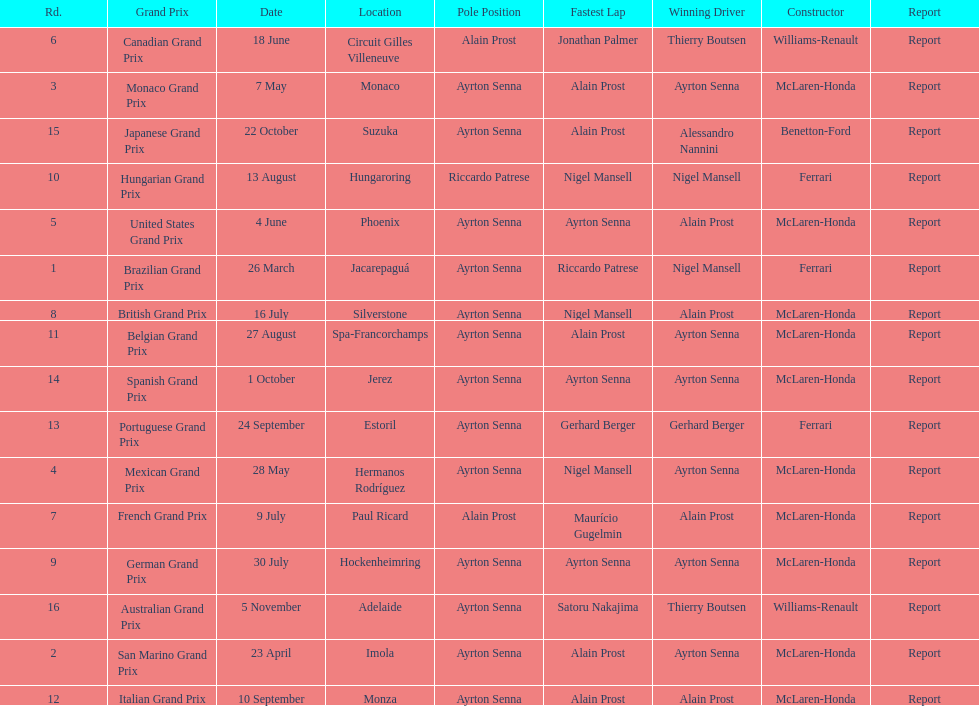What grand prix was before the san marino grand prix? Brazilian Grand Prix. 